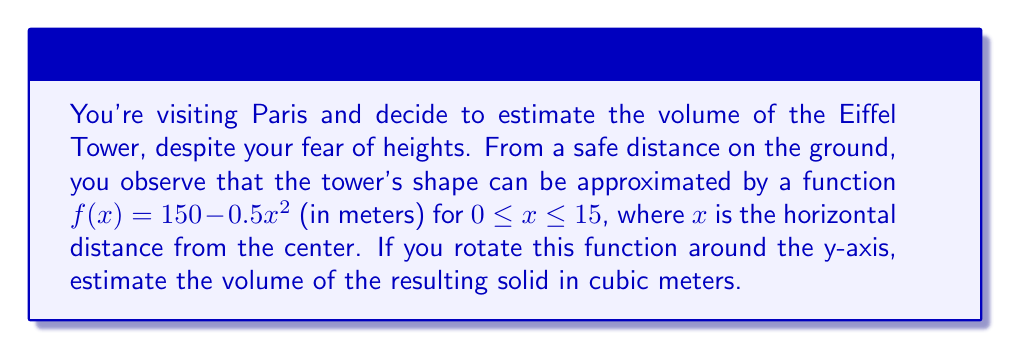Solve this math problem. To estimate the volume of the Eiffel Tower using the given function, we'll use the method of integration for volumes of revolution around the y-axis. The steps are as follows:

1) The volume of a solid formed by rotating a function $f(x)$ around the y-axis from $a$ to $b$ is given by the formula:

   $$V = \pi \int_a^b [f^{-1}(y)]^2 dy$$

2) We need to express $x$ in terms of $y$. From the given function:

   $y = 150 - 0.5x^2$
   $0.5x^2 = 150 - y$
   $x^2 = 300 - 2y$
   $x = \sqrt{300 - 2y}$

3) The limits of integration will be from $y = 150$ (when $x = 0$) to $y = 0$ (when $x = 15$).

4) Substituting into the volume formula:

   $$V = \pi \int_0^{150} (300 - 2y) dy$$

5) Evaluating the integral:

   $$\begin{align}
   V &= \pi [300y - y^2]_0^{150} \\
   &= \pi [(300 \cdot 150 - 150^2) - (300 \cdot 0 - 0^2)] \\
   &= \pi (45000 - 22500) \\
   &= 22500\pi
   \end{align}$$

6) Therefore, the estimated volume is $22500\pi$ cubic meters.

[asy]
import graph;
size(200,200);
real f(real x) {return 150-0.5*x^2;}
draw(graph(f,0,15),blue);
draw((0,0)--(0,150),arrow=Arrow(TeXHead));
draw((0,0)--(15,0),arrow=Arrow(TeXHead));
label("y",(-1,150),W);
label("x",(15,-1),S);
label("y = 150 - 0.5x^2",(10,100),E);
[/asy]
Answer: $22500\pi$ cubic meters (approximately 70,685.8 cubic meters) 